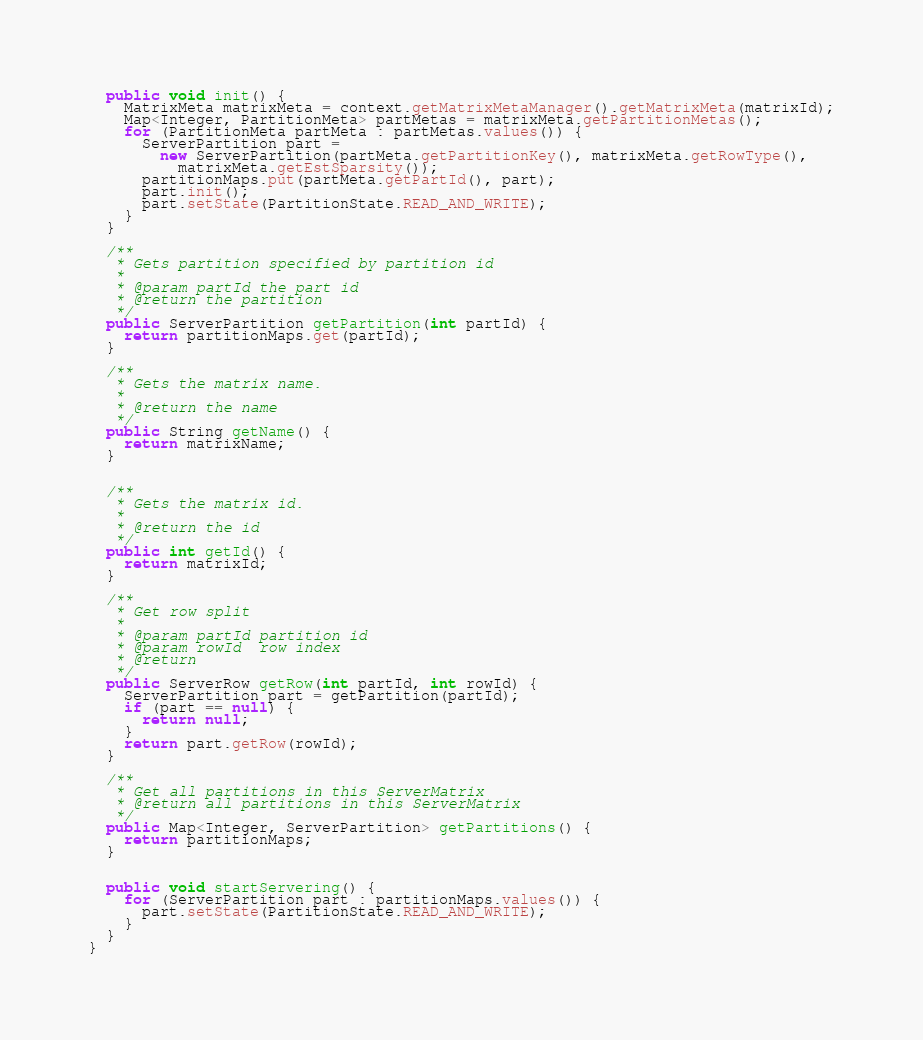Convert code to text. <code><loc_0><loc_0><loc_500><loc_500><_Java_>
  public void init() {
    MatrixMeta matrixMeta = context.getMatrixMetaManager().getMatrixMeta(matrixId);
    Map<Integer, PartitionMeta> partMetas = matrixMeta.getPartitionMetas();
    for (PartitionMeta partMeta : partMetas.values()) {
      ServerPartition part =
        new ServerPartition(partMeta.getPartitionKey(), matrixMeta.getRowType(),
          matrixMeta.getEstSparsity());
      partitionMaps.put(partMeta.getPartId(), part);
      part.init();
      part.setState(PartitionState.READ_AND_WRITE);
    }
  }

  /**
   * Gets partition specified by partition id
   *
   * @param partId the part id
   * @return the partition
   */
  public ServerPartition getPartition(int partId) {
    return partitionMaps.get(partId);
  }

  /**
   * Gets the matrix name.
   *
   * @return the name
   */
  public String getName() {
    return matrixName;
  }


  /**
   * Gets the matrix id.
   *
   * @return the id
   */
  public int getId() {
    return matrixId;
  }

  /**
   * Get row split
   *
   * @param partId partition id
   * @param rowId  row index
   * @return
   */
  public ServerRow getRow(int partId, int rowId) {
    ServerPartition part = getPartition(partId);
    if (part == null) {
      return null;
    }
    return part.getRow(rowId);
  }

  /**
   * Get all partitions in this ServerMatrix
   * @return all partitions in this ServerMatrix
   */
  public Map<Integer, ServerPartition> getPartitions() {
    return partitionMaps;
  }


  public void startServering() {
    for (ServerPartition part : partitionMaps.values()) {
      part.setState(PartitionState.READ_AND_WRITE);
    }
  }
}
</code> 